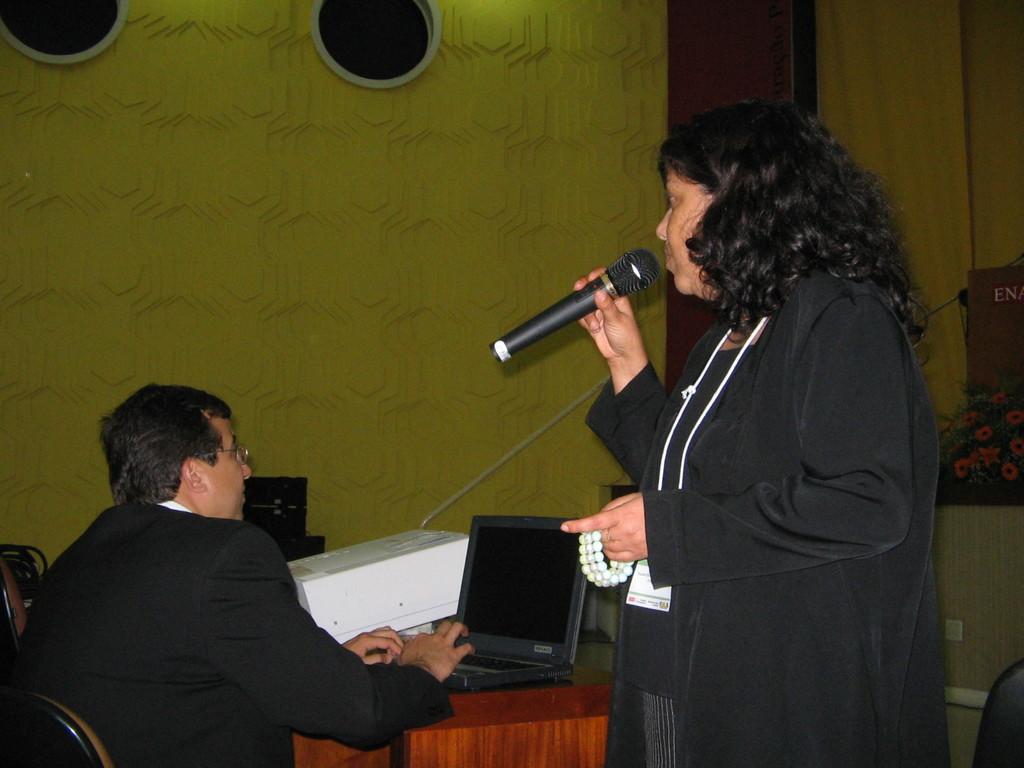Can you describe this image briefly? In this image on the right side there is one woman who is standing and she is holding a mike it seems that she is talking and on the left side there is one man who is sitting on a chair. In front of him there is one table on that table there is one laptop and on the background there is a wall and two windows are there. 